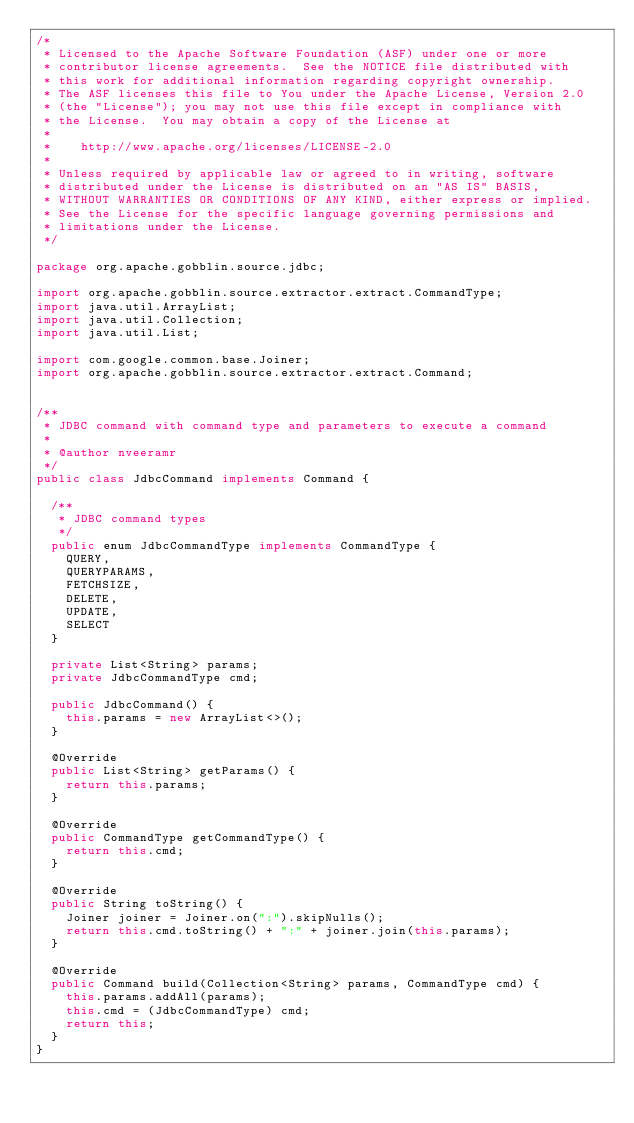<code> <loc_0><loc_0><loc_500><loc_500><_Java_>/*
 * Licensed to the Apache Software Foundation (ASF) under one or more
 * contributor license agreements.  See the NOTICE file distributed with
 * this work for additional information regarding copyright ownership.
 * The ASF licenses this file to You under the Apache License, Version 2.0
 * (the "License"); you may not use this file except in compliance with
 * the License.  You may obtain a copy of the License at
 *
 *    http://www.apache.org/licenses/LICENSE-2.0
 *
 * Unless required by applicable law or agreed to in writing, software
 * distributed under the License is distributed on an "AS IS" BASIS,
 * WITHOUT WARRANTIES OR CONDITIONS OF ANY KIND, either express or implied.
 * See the License for the specific language governing permissions and
 * limitations under the License.
 */

package org.apache.gobblin.source.jdbc;

import org.apache.gobblin.source.extractor.extract.CommandType;
import java.util.ArrayList;
import java.util.Collection;
import java.util.List;

import com.google.common.base.Joiner;
import org.apache.gobblin.source.extractor.extract.Command;


/**
 * JDBC command with command type and parameters to execute a command
 *
 * @author nveeramr
 */
public class JdbcCommand implements Command {

  /**
   * JDBC command types
   */
  public enum JdbcCommandType implements CommandType {
    QUERY,
    QUERYPARAMS,
    FETCHSIZE,
    DELETE,
    UPDATE,
    SELECT
  }

  private List<String> params;
  private JdbcCommandType cmd;

  public JdbcCommand() {
    this.params = new ArrayList<>();
  }

  @Override
  public List<String> getParams() {
    return this.params;
  }

  @Override
  public CommandType getCommandType() {
    return this.cmd;
  }

  @Override
  public String toString() {
    Joiner joiner = Joiner.on(":").skipNulls();
    return this.cmd.toString() + ":" + joiner.join(this.params);
  }

  @Override
  public Command build(Collection<String> params, CommandType cmd) {
    this.params.addAll(params);
    this.cmd = (JdbcCommandType) cmd;
    return this;
  }
}
</code> 